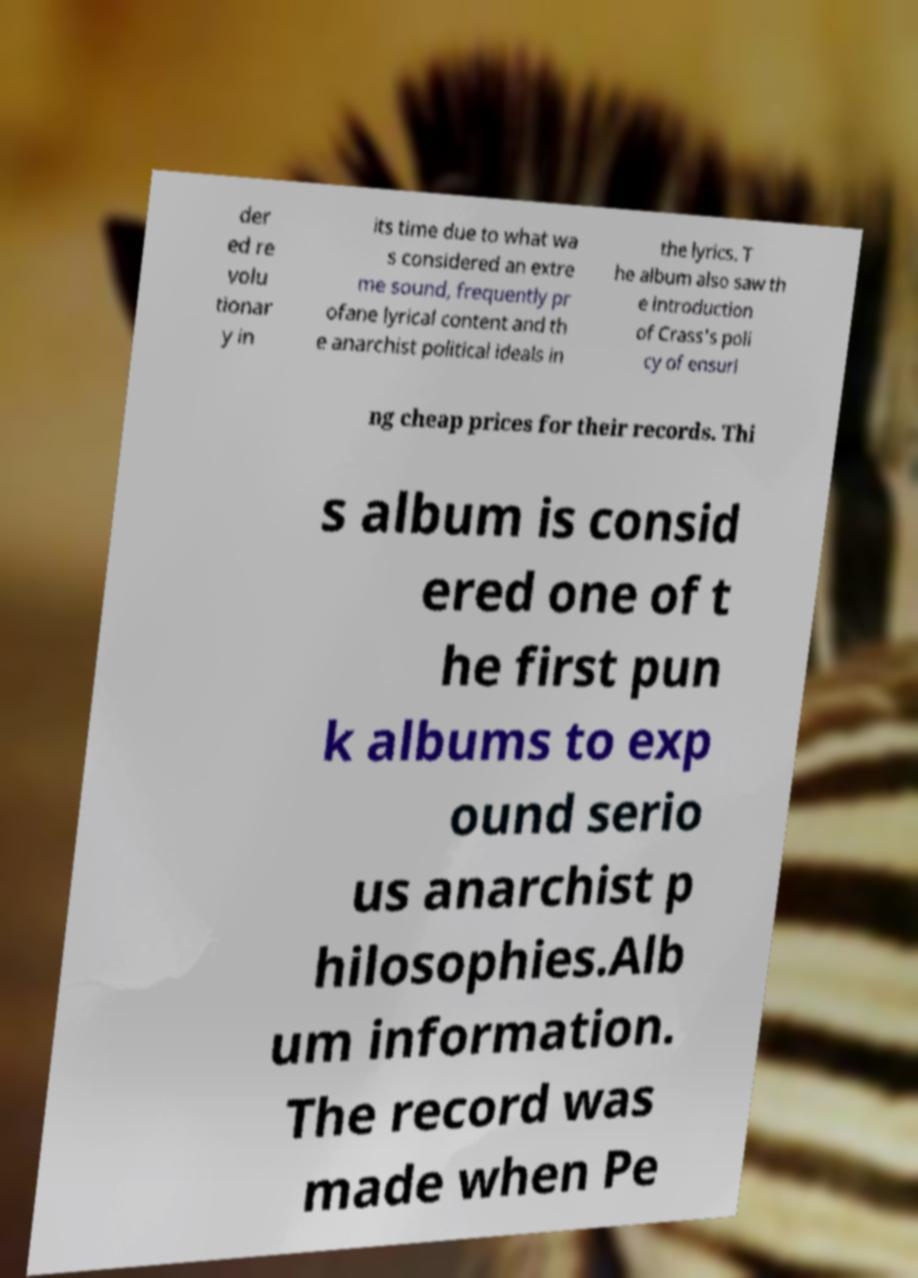Could you extract and type out the text from this image? der ed re volu tionar y in its time due to what wa s considered an extre me sound, frequently pr ofane lyrical content and th e anarchist political ideals in the lyrics. T he album also saw th e introduction of Crass's poli cy of ensuri ng cheap prices for their records. Thi s album is consid ered one of t he first pun k albums to exp ound serio us anarchist p hilosophies.Alb um information. The record was made when Pe 